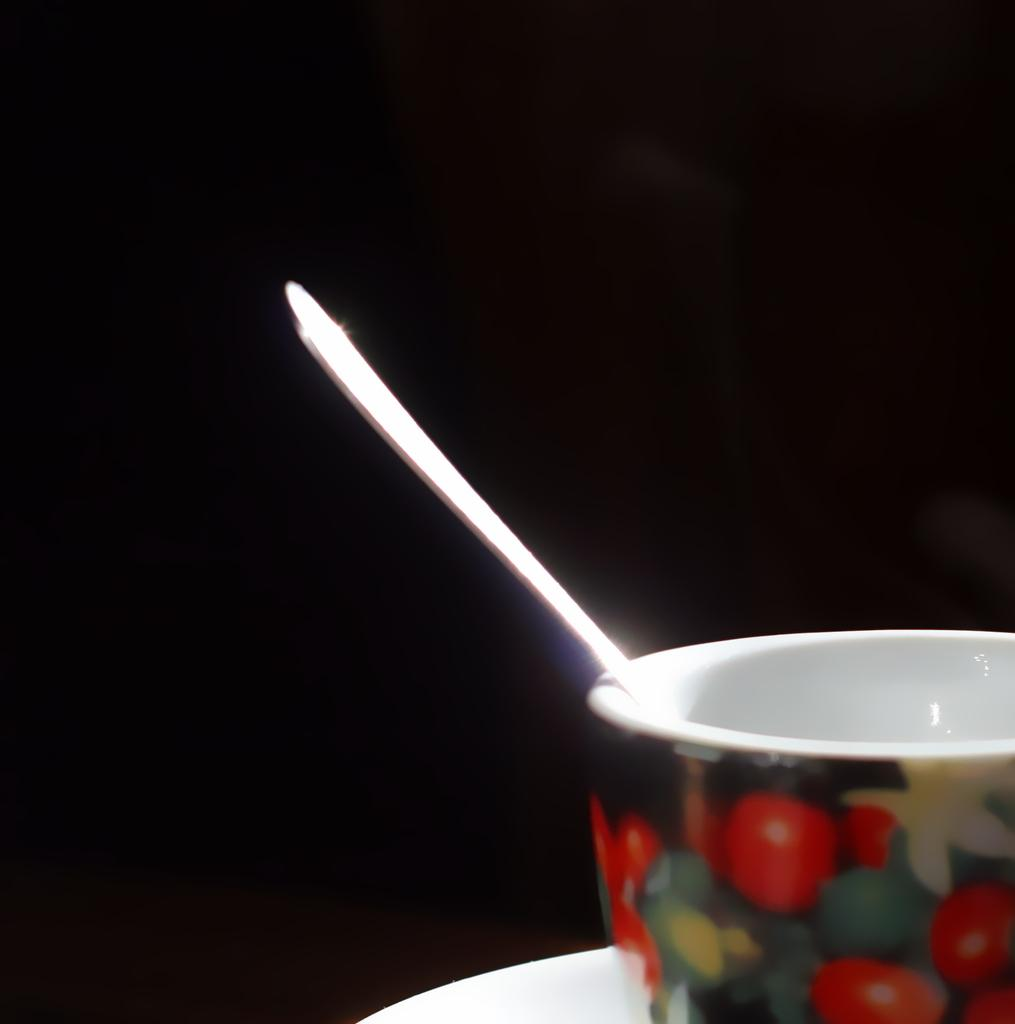What is in the bowl that has a design in the image? There is a bowl with a design in the image. What is inside the bowl with the design? There is a spoon in the bowl. How would you describe the overall appearance of the image? The background of the image is dark. What is the value of the baseball patch in the image? There is no baseball or patch present in the image. 